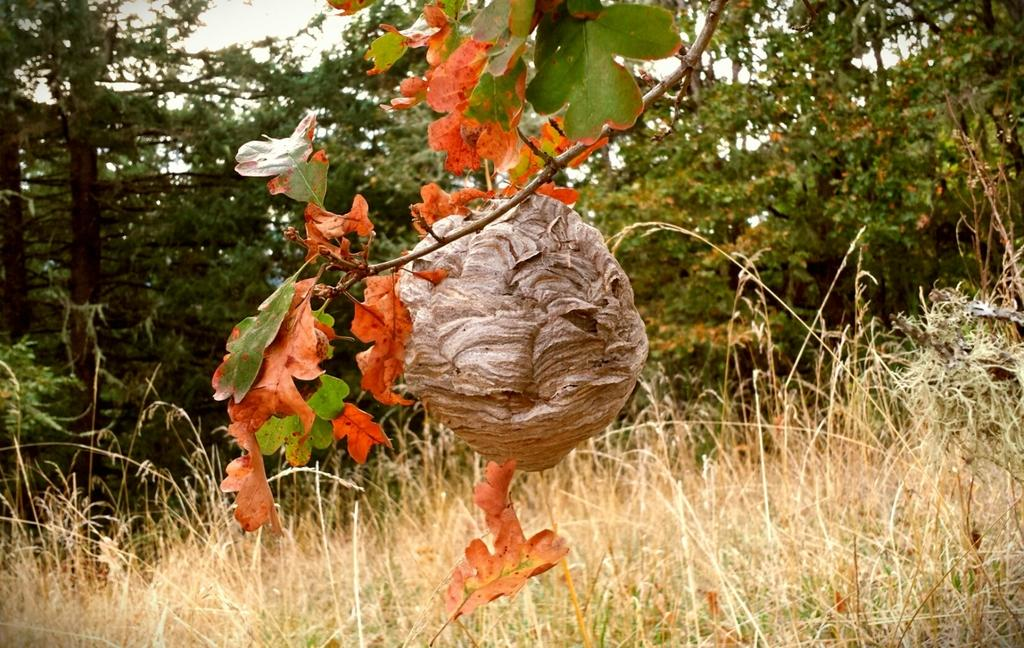What type of vegetation can be seen in the image? There are trees in the image. What is located in the foreground of the image? There is a nest in the foreground of the image. What is visible at the top of the image? The sky is visible at the top of the image. What type of ground cover is present at the bottom of the image? Grass is present at the bottom of the image. How many clocks are hanging from the trees in the image? There are no clocks present in the image; it features trees, a nest, and grass. Is there a veil covering the nest in the image? There is no veil present in the image; the nest is visible and not covered. 